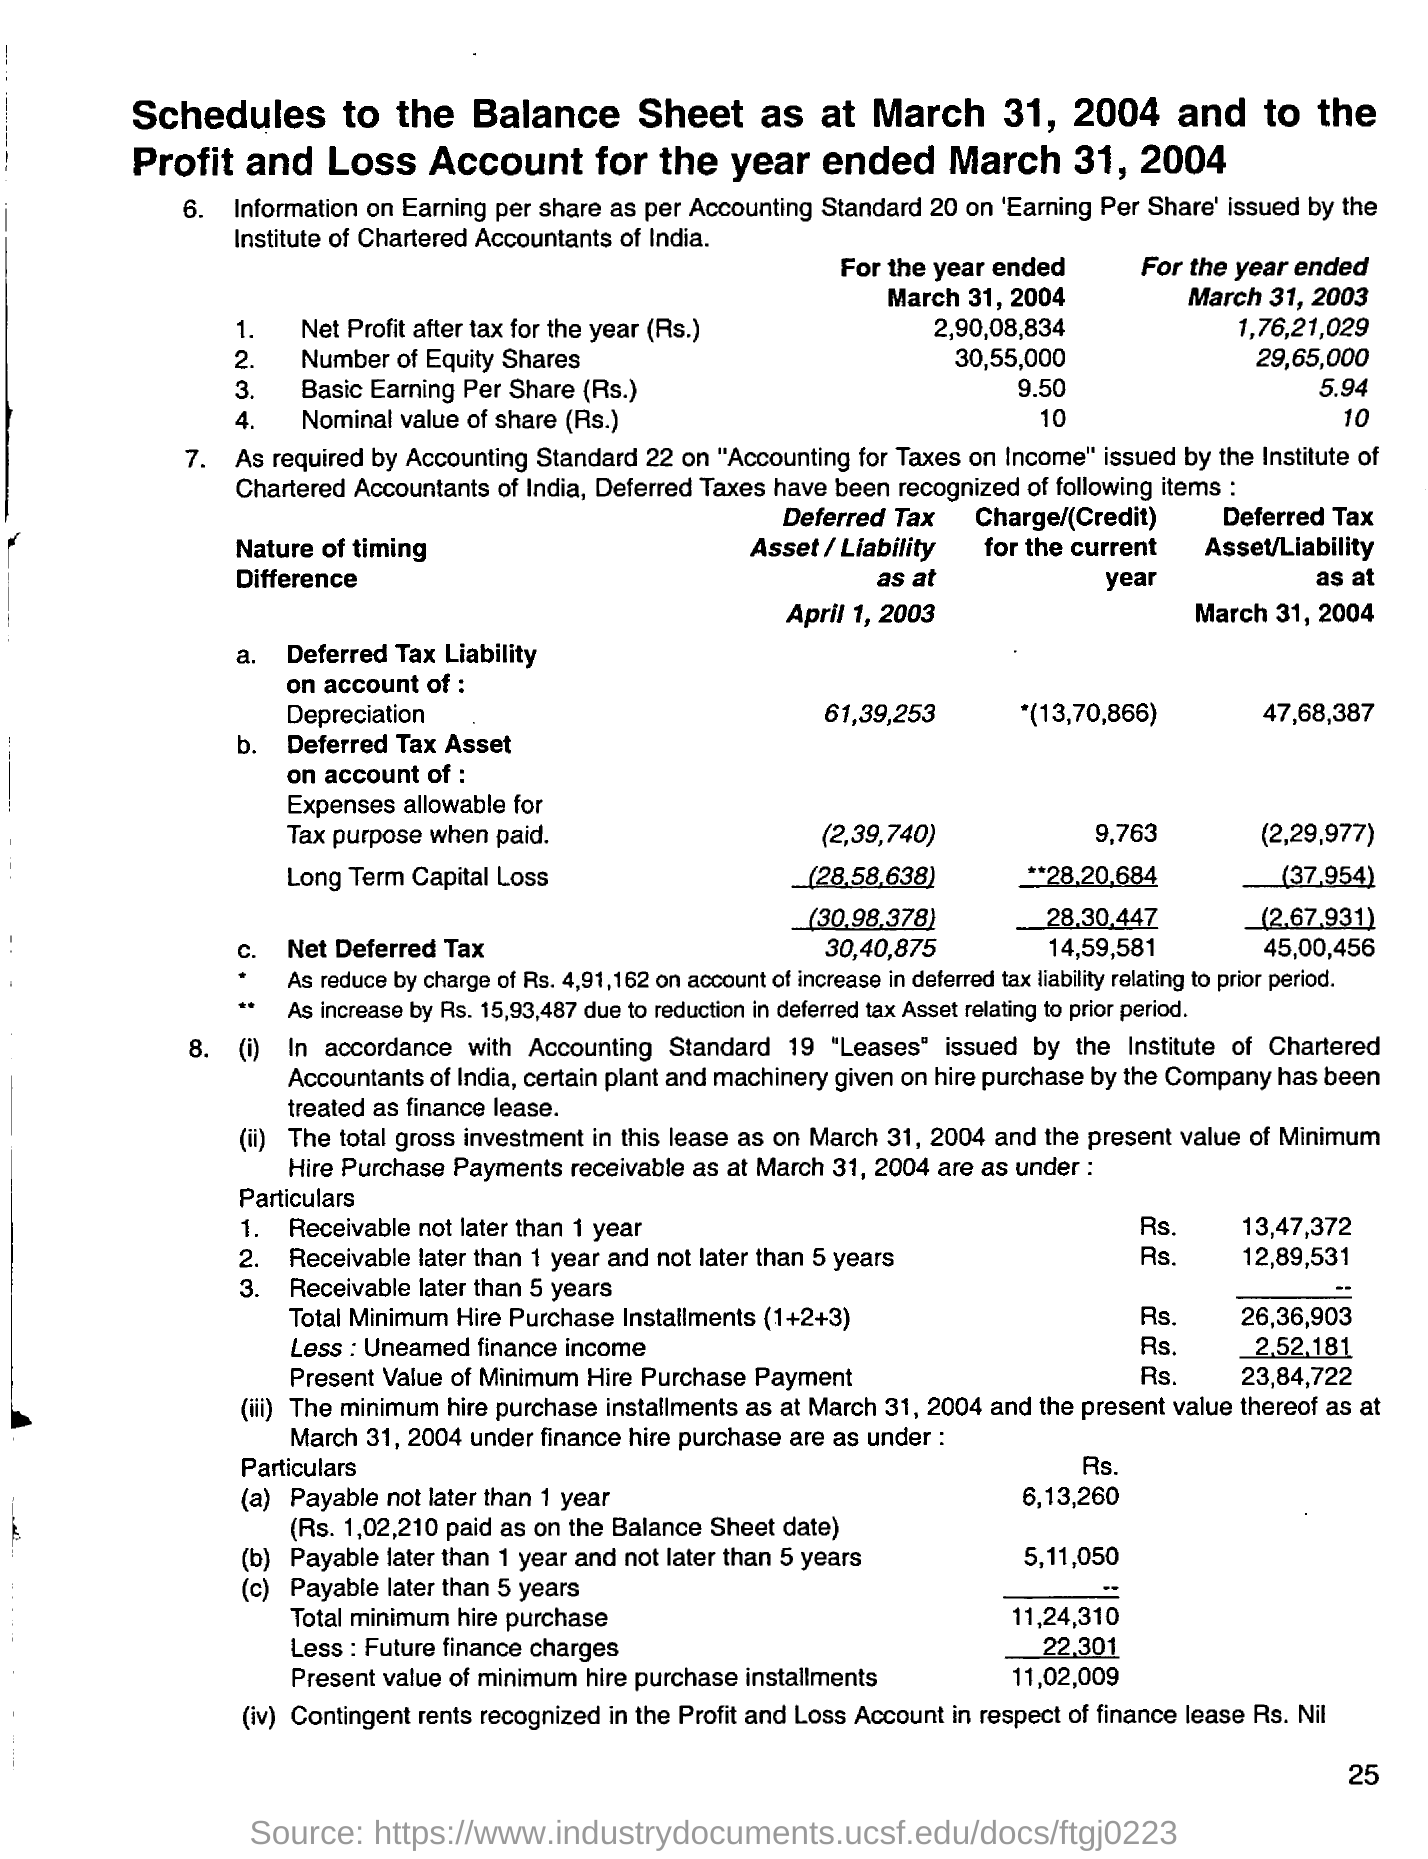What is the net profit after tax for the year(rs) ended march 31, 2004?
Your answer should be compact. 2,90,08,834. What is the deferred tax liability on account of depreciation as at april 1, 2003 ?
Ensure brevity in your answer.  61,39,253. What is the nominal value of the share for the year ended march 31 , 2004
Your answer should be compact. 10. What is the nominal value of the share for the year ended march 31 , 2003
Offer a very short reply. 10. What is the net profit after tax for the year ended march 31, 2003?
Provide a short and direct response. 1,76,21,029. What is the basic earning per share for the year ended march 31, 2004 ?
Keep it short and to the point. 9.50. What is the basic earning per share for the year ended march 31, 2003
Provide a short and direct response. 5.94. What is the deferred tax liability on account of depreciation as at march 31, 2004 ?
Offer a very short reply. 47,68,387. What is the number of equity shares for the year ended march 31,2004?
Keep it short and to the point. 30,55,000. What is the number of equity shares(rs) for the year ended march 31,2003?
Keep it short and to the point. 29,65000. 